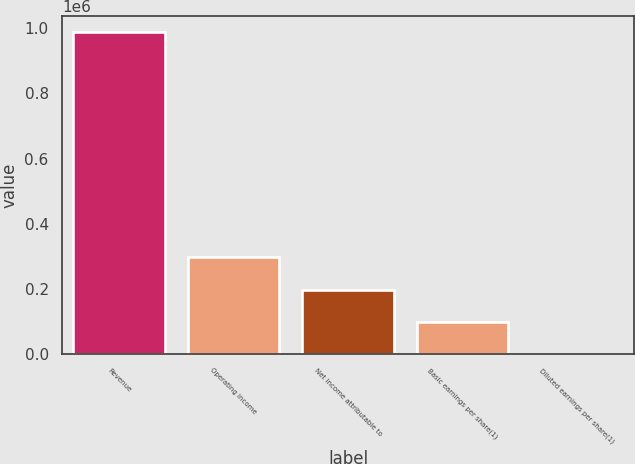Convert chart to OTSL. <chart><loc_0><loc_0><loc_500><loc_500><bar_chart><fcel>Revenue<fcel>Operating income<fcel>Net income attributable to<fcel>Basic earnings per share(1)<fcel>Diluted earnings per share(1)<nl><fcel>987860<fcel>296358<fcel>197572<fcel>98786.6<fcel>0.62<nl></chart> 